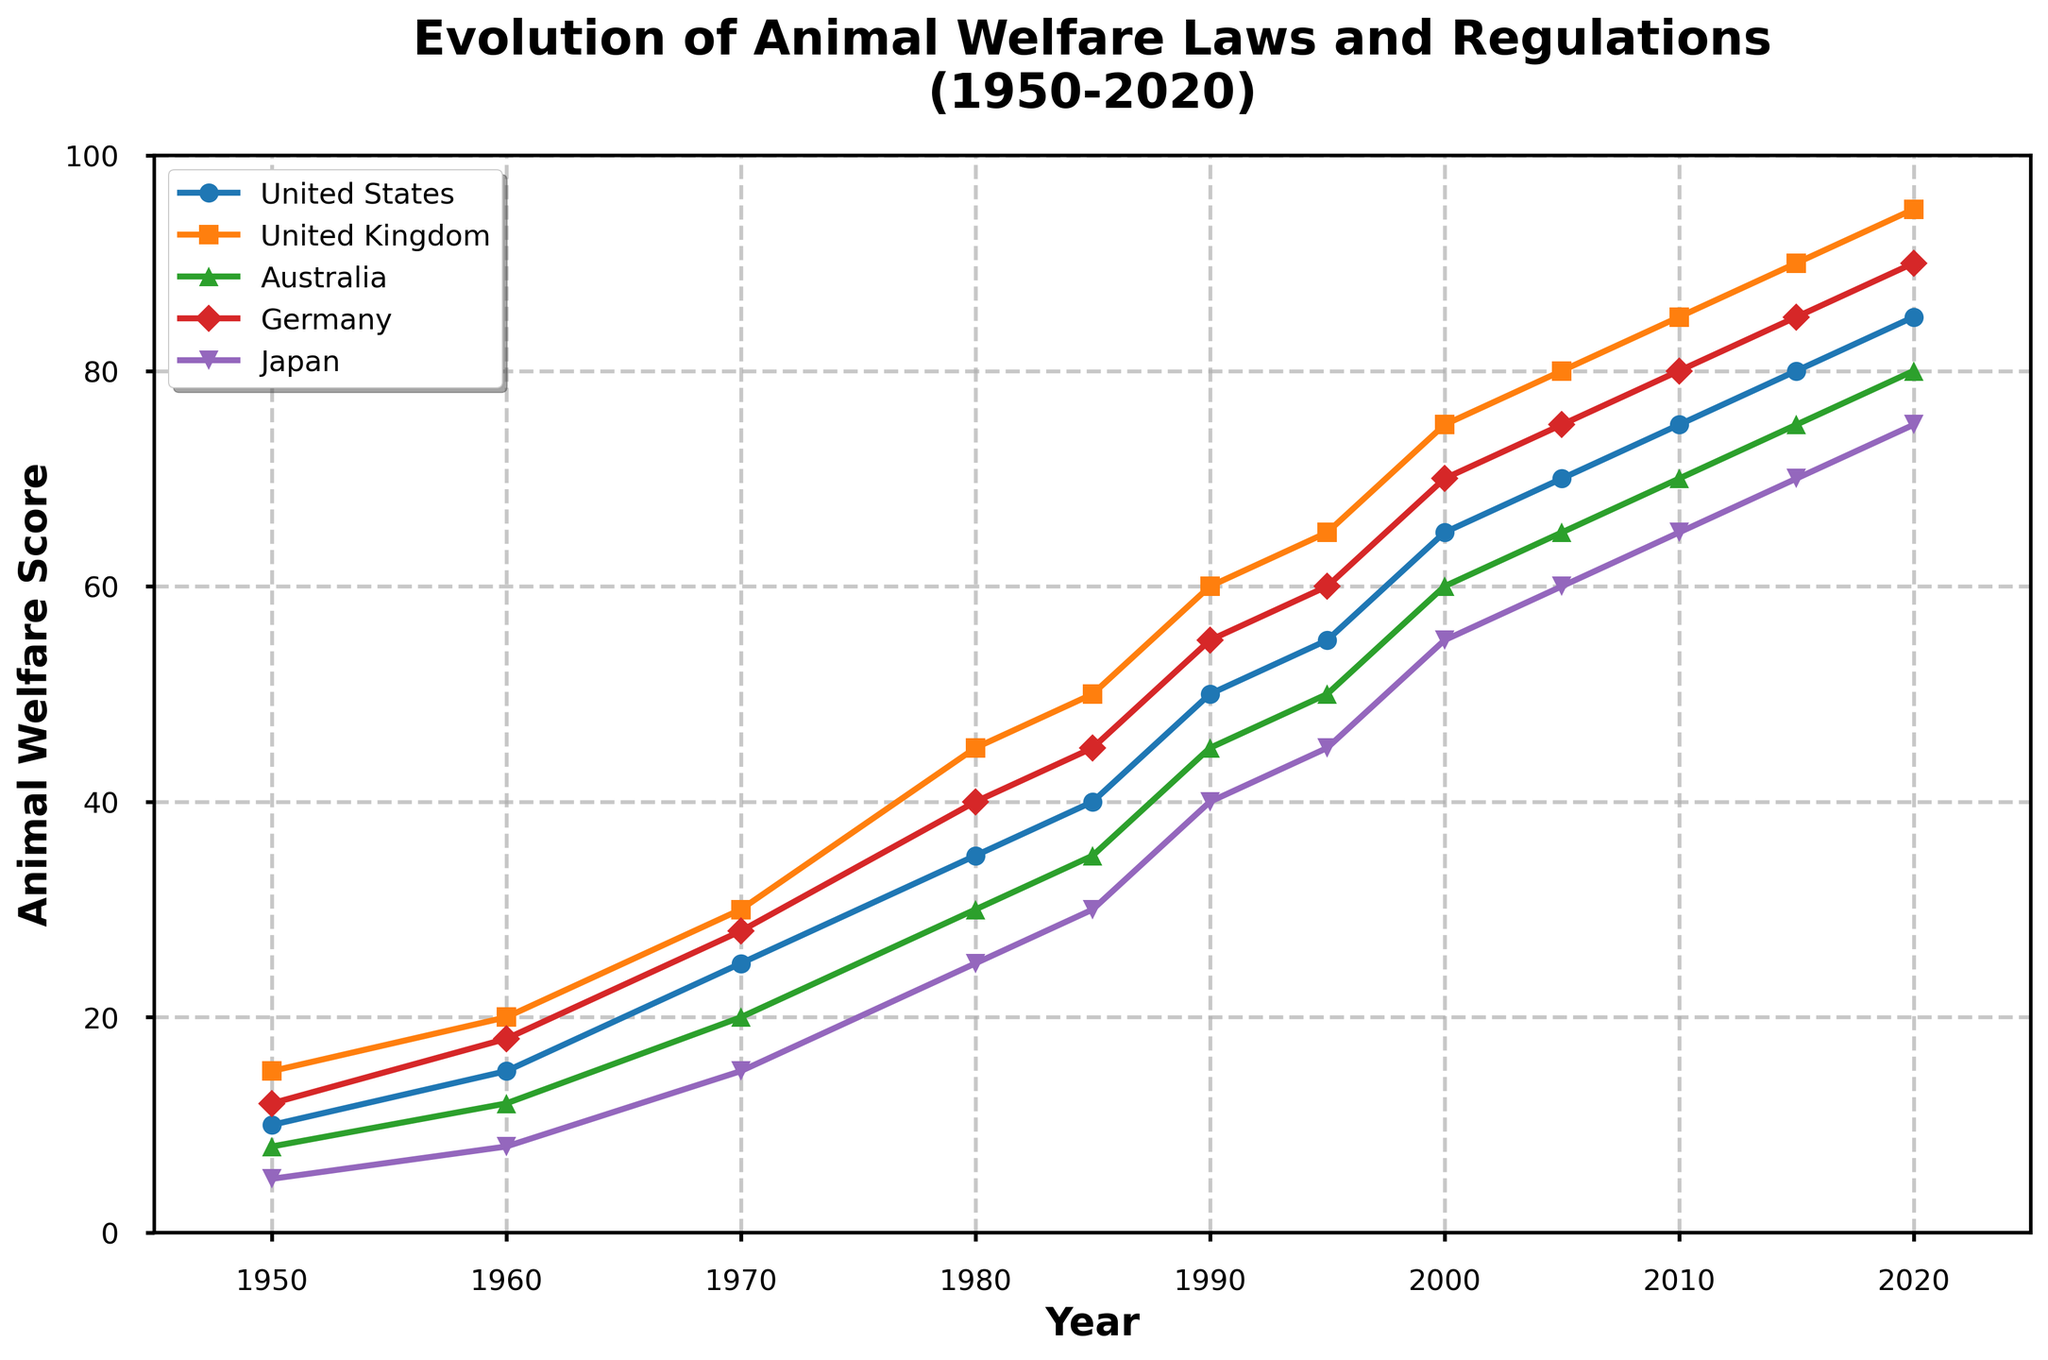Which country had the highest animal welfare score in 1970? Look at the scores for each country in 1970. The United Kingdom had the highest score with 30.
Answer: United Kingdom What was the difference in the animal welfare score between the United States and Germany in 1995? Subtract Germany's score from the United States' score in 1995: 55 - 60 = -5.
Answer: -5 How did the animal welfare score in Japan change from 1950 to 2020? Subtract Japan's score in 1950 from its score in 2020: 75 - 5 = 70.
Answer: 70 Compare the trends in animal welfare scores between Australia and the United Kingdom over the years. Which country had a steadier increase? Observing the graph, both countries' scores increased, but the United Kingdom had a steadier and more significant increase compared to Australia.
Answer: United Kingdom In which year did the United States' animal welfare score reach 50? Locate the year on the graph where the United States' score reached 50, which is 1990.
Answer: 1990 What is the average animal welfare score of Germany between 1950 and 2000? Sum Germany's scores between 1950 and 2000 and divide by the number of years: (12+18+28+40+45+55+60+70)/8 = 40.
Answer: 40 Which country showed the highest improvement in animal welfare score from 1950 to 2020? Calculate the increase for each country and compare. The United States improved by 75 (85-10), UK by 80 (95-15), Australia by 72 (80-8), Germany by 78 (90-12), and Japan by 70 (75-5). The United Kingdom showed the highest improvement.
Answer: United Kingdom At what year did Japan reach an animal welfare score of 40? Locate the year on the graph where Japan's score was first recorded as 40, which is 1990.
Answer: 1990 Among the five countries, which one had the lowest animal welfare score in 1980? Look at the scores for each country in 1980. Japan had the lowest score with 25.
Answer: Japan Between 1980 and 2010, which country had the highest overall increase in animal welfare score? Calculate the increase for each country from 1980 to 2010. The United States increased by 40 (75-35), UK by 40 (85-45), Australia by 40 (70-30), Germany by 40 (80-40), and Japan by 40 (65-25). All countries had an equal increase of 40.
Answer: Equal increase 